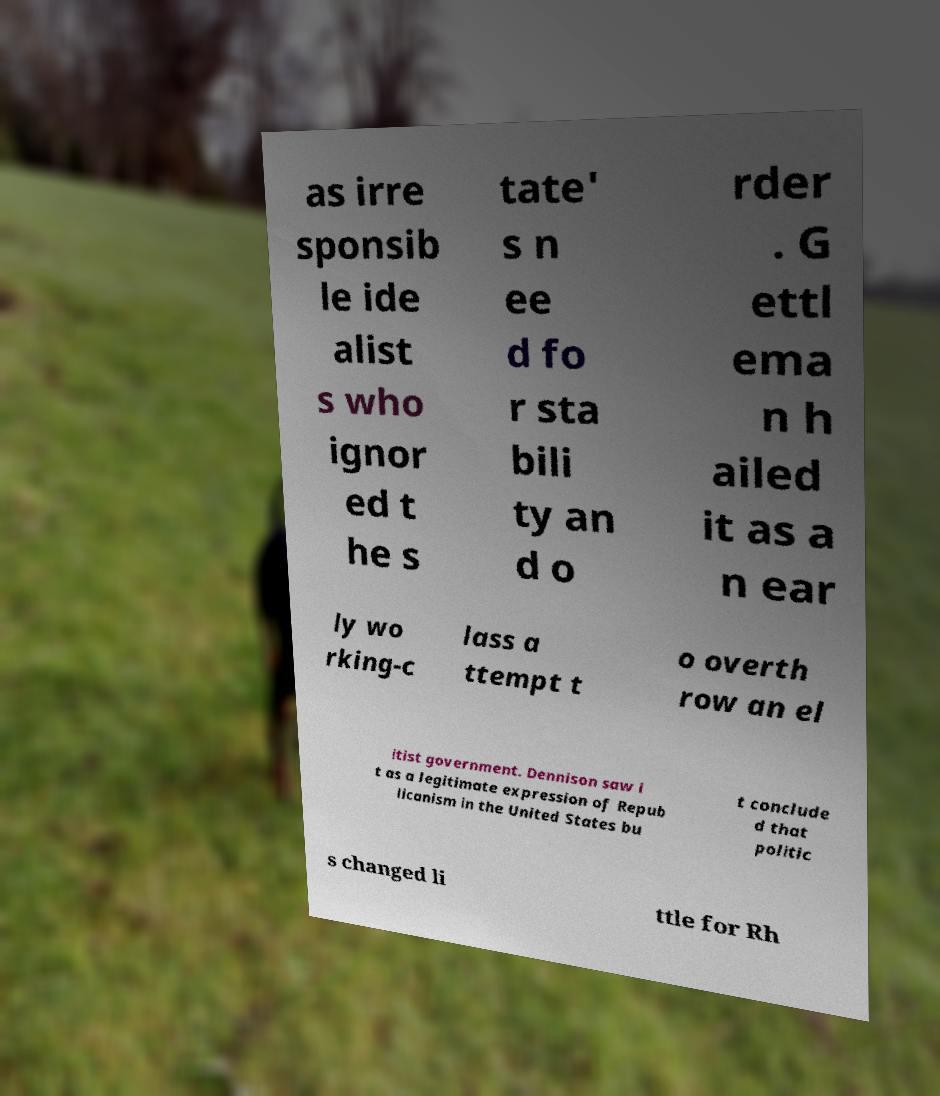Can you read and provide the text displayed in the image?This photo seems to have some interesting text. Can you extract and type it out for me? as irre sponsib le ide alist s who ignor ed t he s tate' s n ee d fo r sta bili ty an d o rder . G ettl ema n h ailed it as a n ear ly wo rking-c lass a ttempt t o overth row an el itist government. Dennison saw i t as a legitimate expression of Repub licanism in the United States bu t conclude d that politic s changed li ttle for Rh 